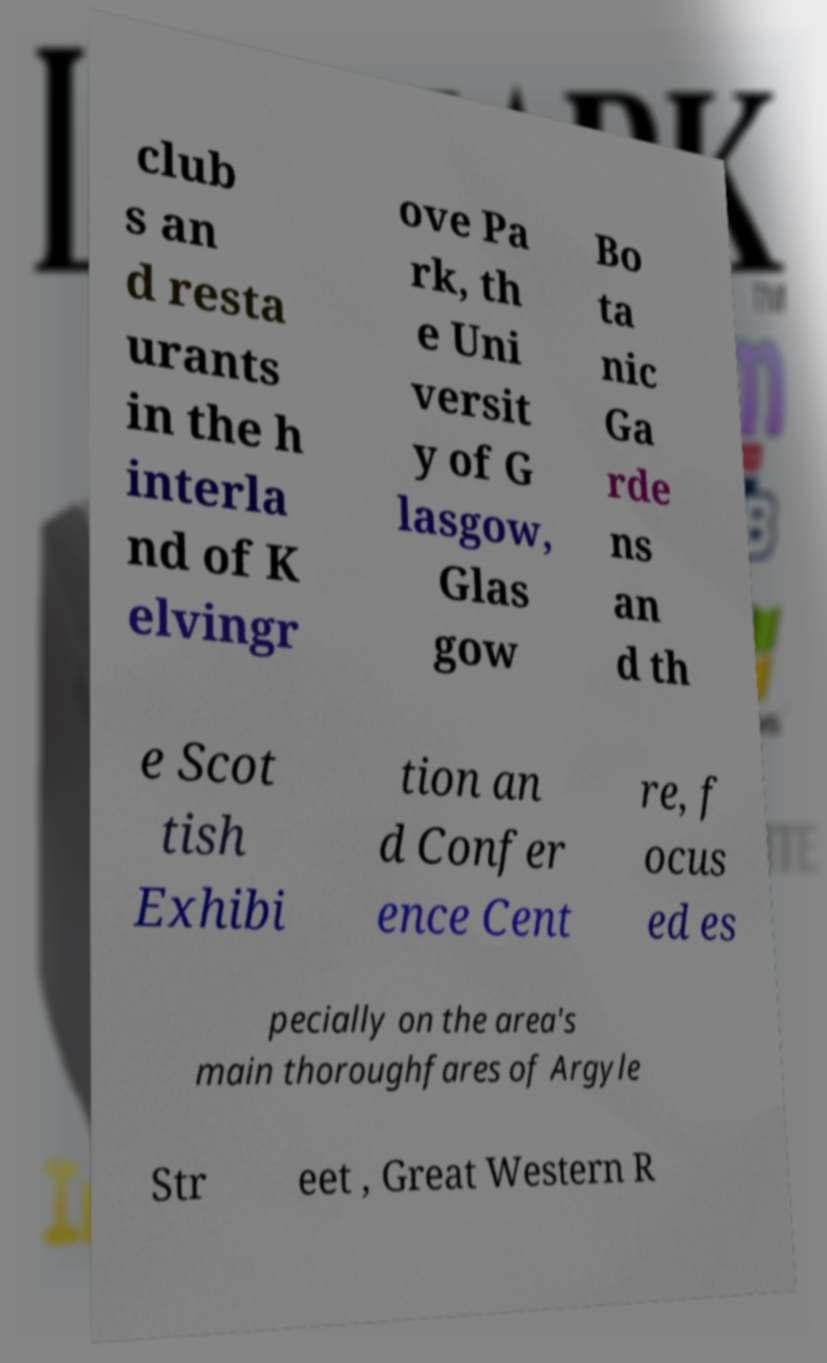Can you accurately transcribe the text from the provided image for me? club s an d resta urants in the h interla nd of K elvingr ove Pa rk, th e Uni versit y of G lasgow, Glas gow Bo ta nic Ga rde ns an d th e Scot tish Exhibi tion an d Confer ence Cent re, f ocus ed es pecially on the area's main thoroughfares of Argyle Str eet , Great Western R 